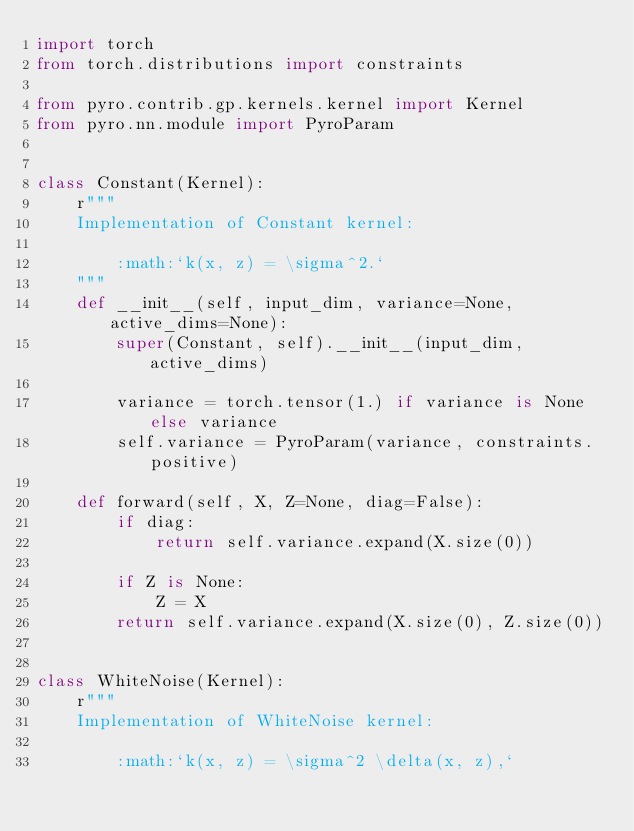Convert code to text. <code><loc_0><loc_0><loc_500><loc_500><_Python_>import torch
from torch.distributions import constraints

from pyro.contrib.gp.kernels.kernel import Kernel
from pyro.nn.module import PyroParam


class Constant(Kernel):
    r"""
    Implementation of Constant kernel:

        :math:`k(x, z) = \sigma^2.`
    """
    def __init__(self, input_dim, variance=None, active_dims=None):
        super(Constant, self).__init__(input_dim, active_dims)

        variance = torch.tensor(1.) if variance is None else variance
        self.variance = PyroParam(variance, constraints.positive)

    def forward(self, X, Z=None, diag=False):
        if diag:
            return self.variance.expand(X.size(0))

        if Z is None:
            Z = X
        return self.variance.expand(X.size(0), Z.size(0))


class WhiteNoise(Kernel):
    r"""
    Implementation of WhiteNoise kernel:

        :math:`k(x, z) = \sigma^2 \delta(x, z),`
</code> 